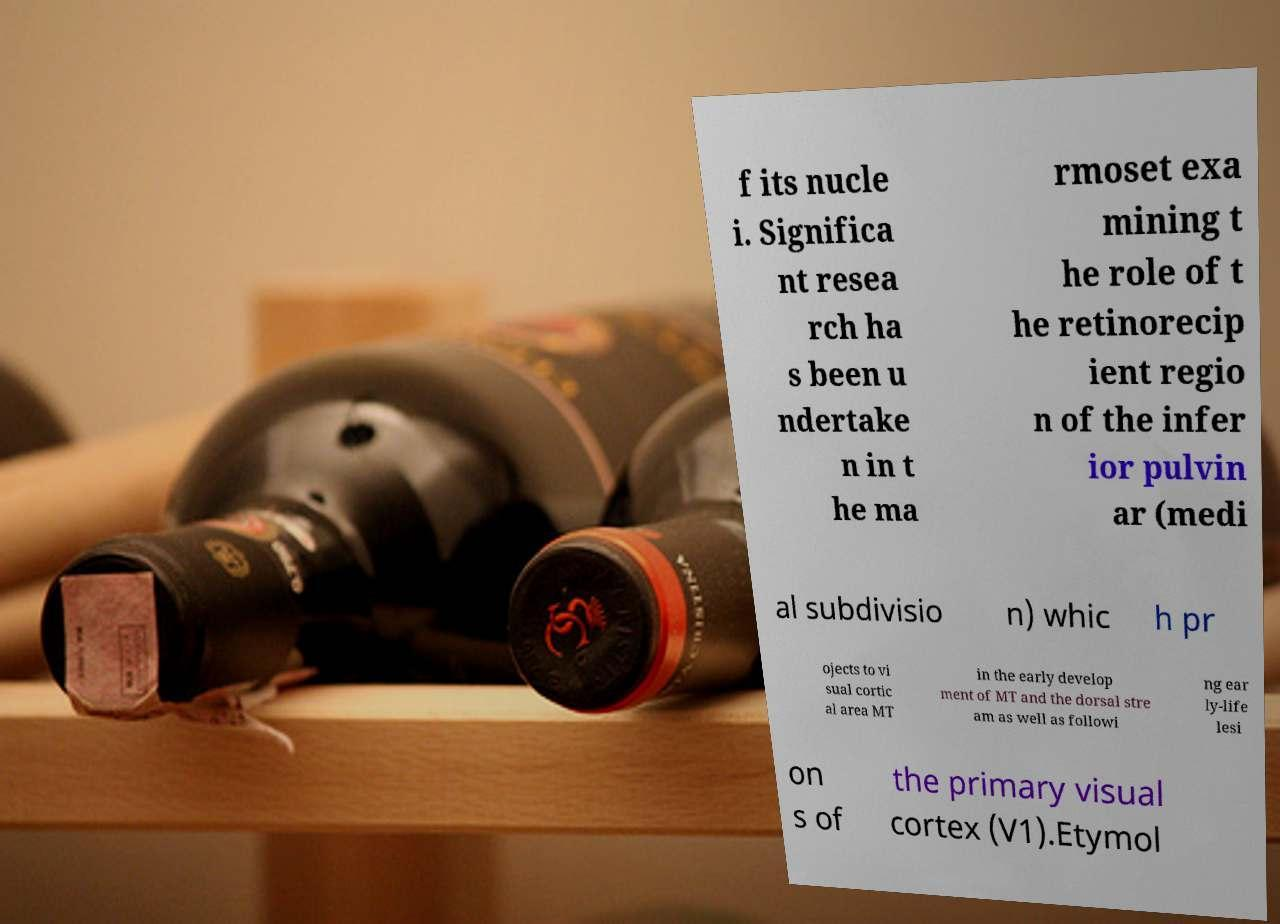There's text embedded in this image that I need extracted. Can you transcribe it verbatim? f its nucle i. Significa nt resea rch ha s been u ndertake n in t he ma rmoset exa mining t he role of t he retinorecip ient regio n of the infer ior pulvin ar (medi al subdivisio n) whic h pr ojects to vi sual cortic al area MT in the early develop ment of MT and the dorsal stre am as well as followi ng ear ly-life lesi on s of the primary visual cortex (V1).Etymol 